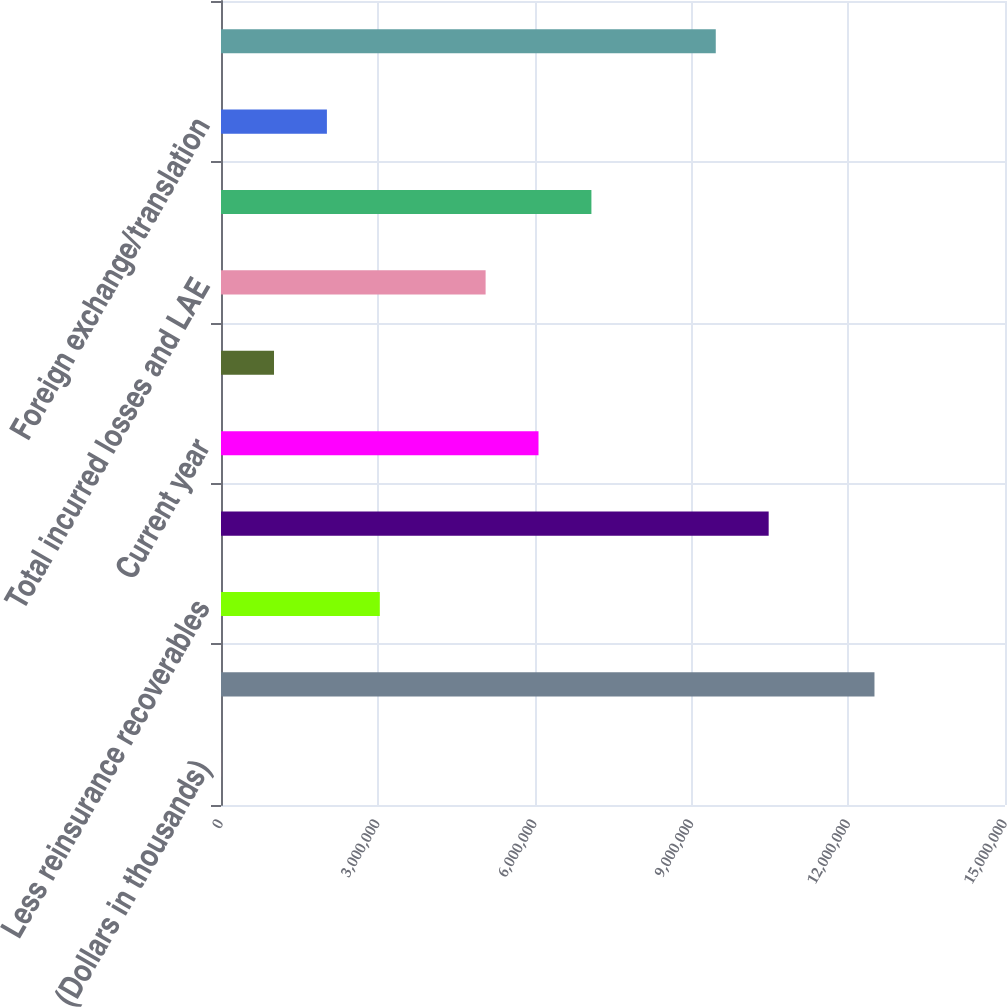<chart> <loc_0><loc_0><loc_500><loc_500><bar_chart><fcel>(Dollars in thousands)<fcel>Gross reserves at January 1<fcel>Less reinsurance recoverables<fcel>Net reserves at January 1<fcel>Current year<fcel>Prior years<fcel>Total incurred losses and LAE<fcel>Total paid losses and LAE<fcel>Foreign exchange/translation<fcel>Net reserves at December 31<nl><fcel>2012<fcel>1.25027e+07<fcel>3.03837e+06<fcel>1.04784e+07<fcel>6.07473e+06<fcel>1.01413e+06<fcel>5.06261e+06<fcel>7.08685e+06<fcel>2.02625e+06<fcel>9.4663e+06<nl></chart> 